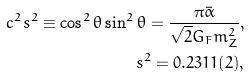<formula> <loc_0><loc_0><loc_500><loc_500>c ^ { 2 } s ^ { 2 } \equiv \cos ^ { 2 } \theta \sin ^ { 2 } \theta = \frac { \pi \bar { \alpha } } { \sqrt { 2 } G _ { F } m _ { Z } ^ { 2 } } , \\ s ^ { 2 } = 0 . 2 3 1 1 ( 2 ) ,</formula> 